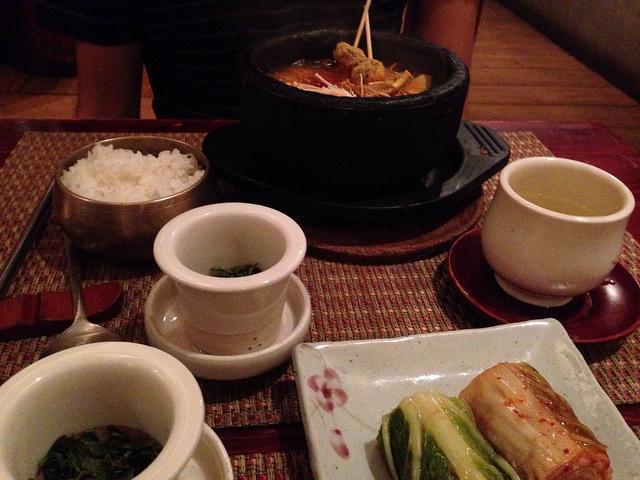What is the black pot used for?
Choose the right answer from the provided options to respond to the question.
Options: Fondue, rice, sushi, tempura. Fondue. 